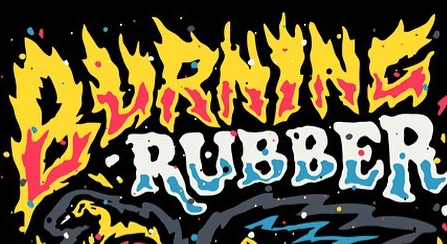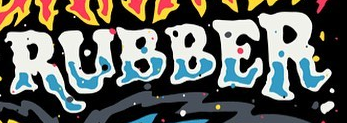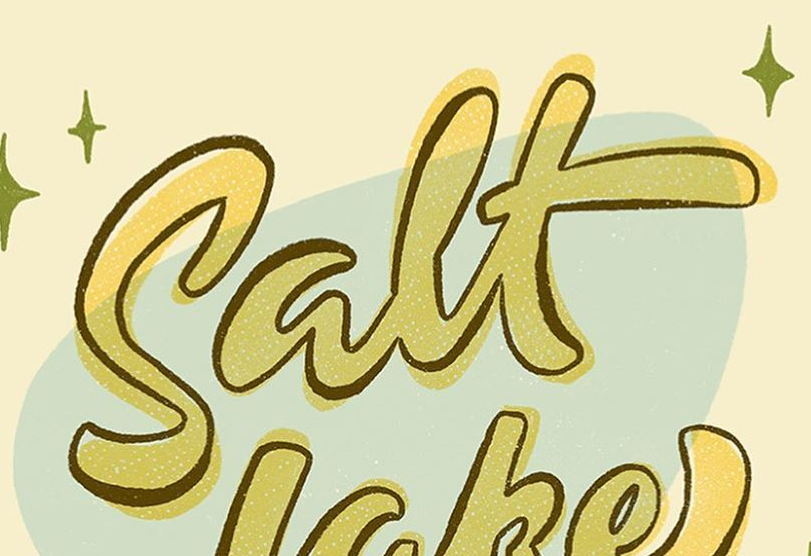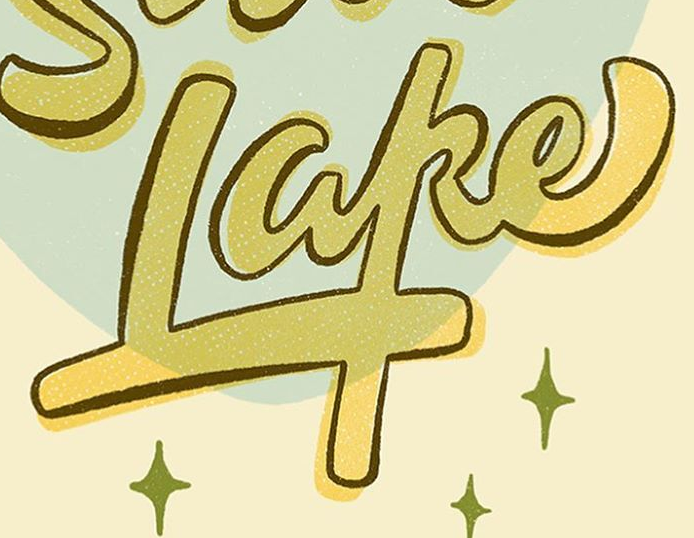What text is displayed in these images sequentially, separated by a semicolon? BURNINC; RUBBER; Salt; Lake 